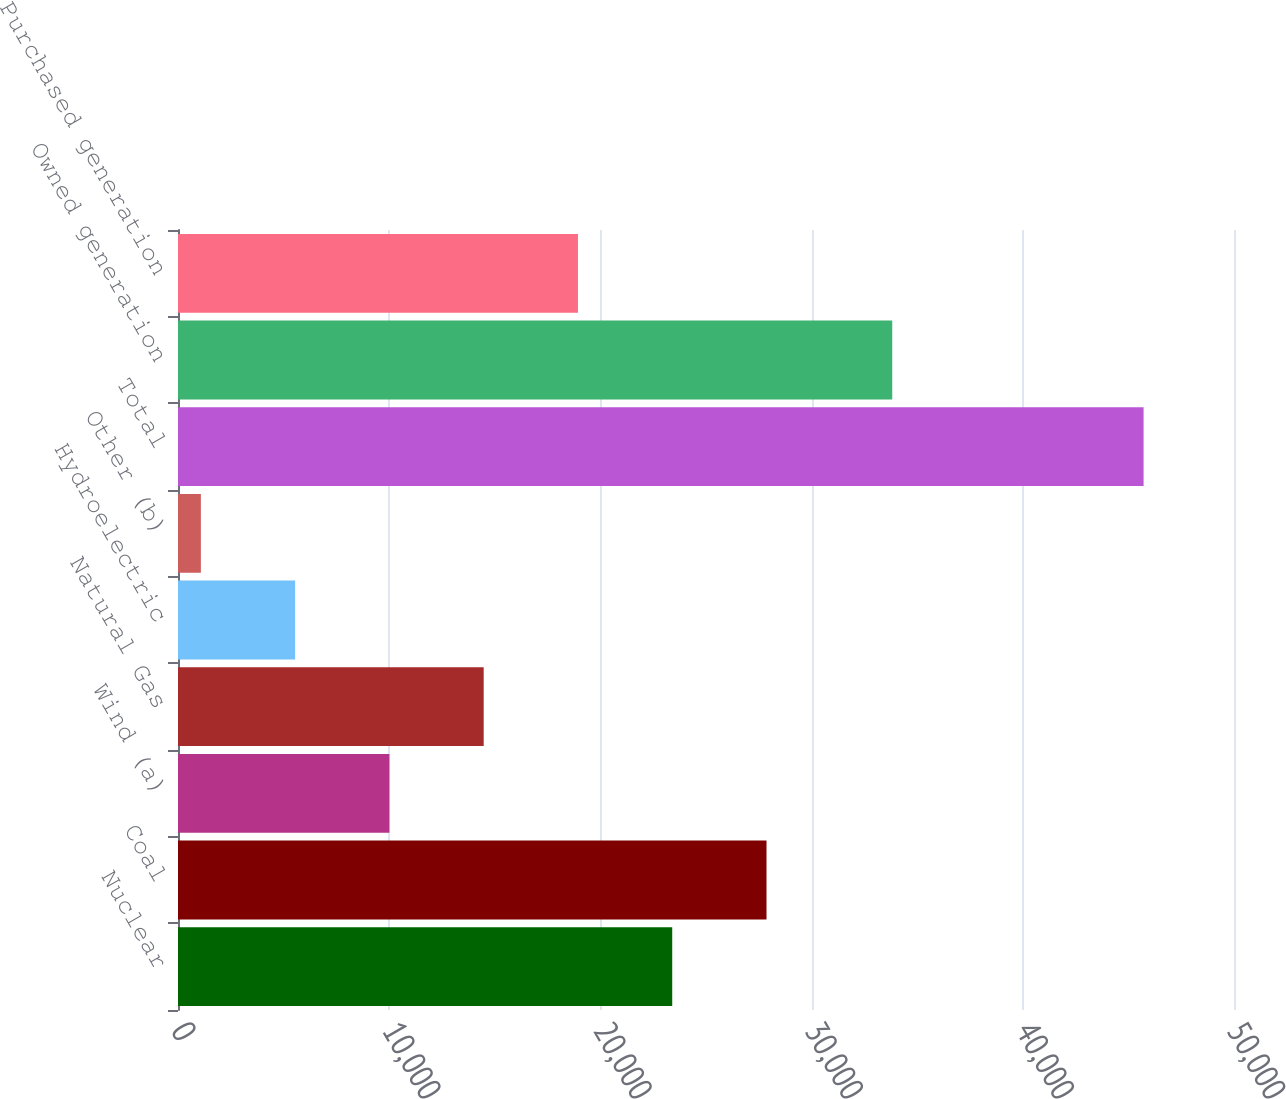<chart> <loc_0><loc_0><loc_500><loc_500><bar_chart><fcel>Nuclear<fcel>Coal<fcel>Wind (a)<fcel>Natural Gas<fcel>Hydroelectric<fcel>Other (b)<fcel>Total<fcel>Owned generation<fcel>Purchased generation<nl><fcel>23401<fcel>27864.6<fcel>10010.2<fcel>14473.8<fcel>5546.6<fcel>1083<fcel>45719<fcel>33818<fcel>18937.4<nl></chart> 